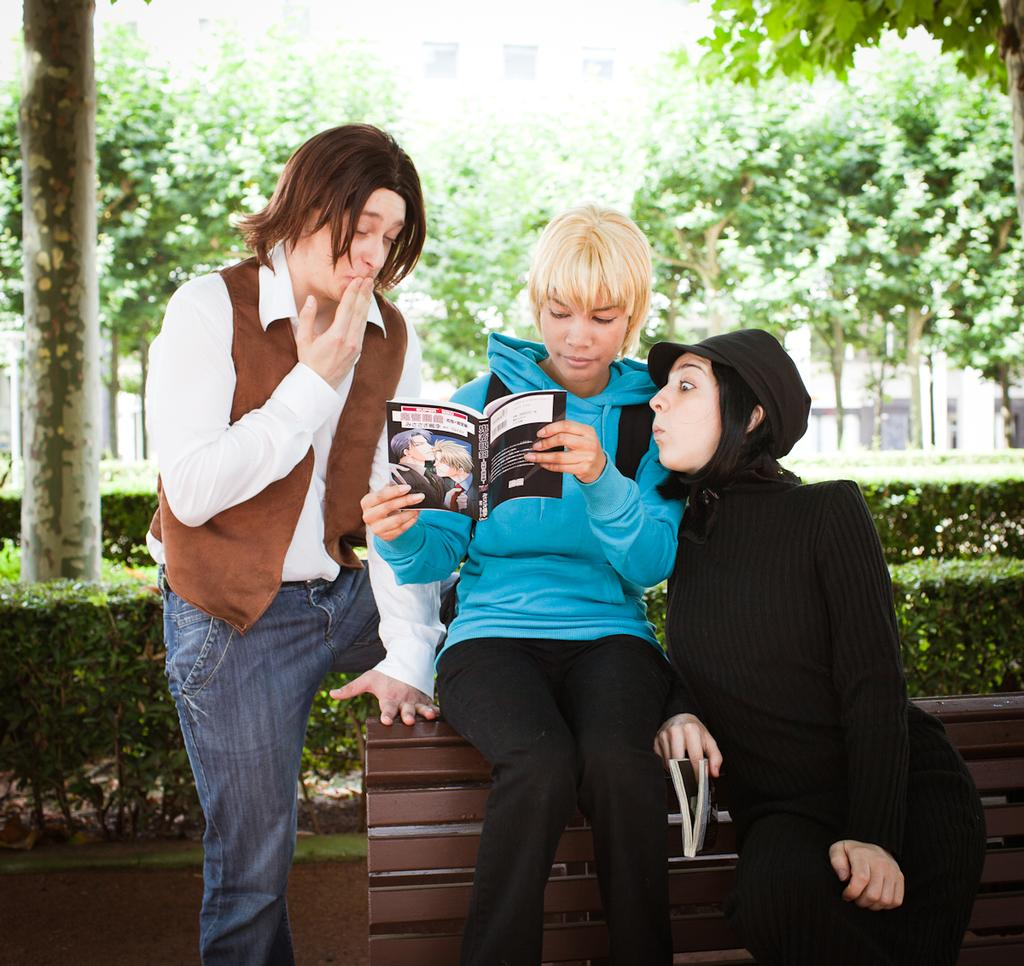How many people are in the image? There are three persons in the image. What are two of the persons holding? Two of the persons are holding books. What is the seating arrangement in the image? There is a bench in the image. What type of vegetation is present in the image? There are plants and trees in the image. What can be seen in the background of the image? There is a building with windows in the background of the image. What type of ocean can be seen in the image? There is no ocean present in the image; it features a bench, plants, trees, and a building with windows. What instrument is being played by the person on the left in the image? There is no person playing an instrument in the image; two of the persons are holding books. 